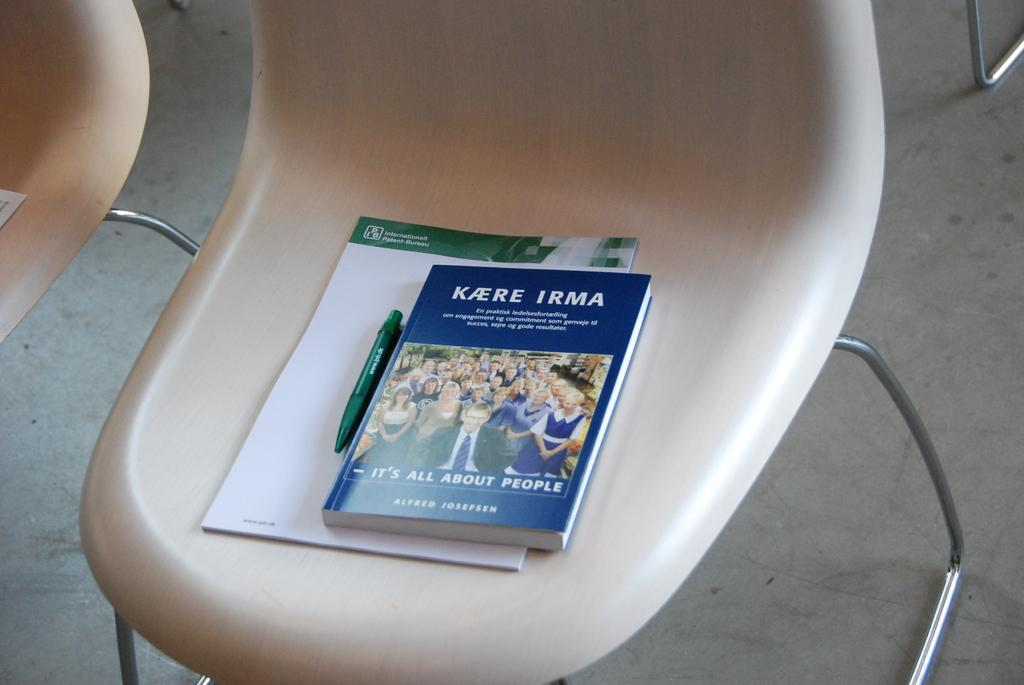<image>
Describe the image concisely. A boot titled Its All About People sits on chair. 